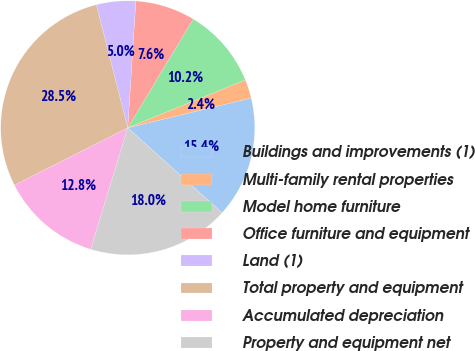Convert chart. <chart><loc_0><loc_0><loc_500><loc_500><pie_chart><fcel>Buildings and improvements (1)<fcel>Multi-family rental properties<fcel>Model home furniture<fcel>Office furniture and equipment<fcel>Land (1)<fcel>Total property and equipment<fcel>Accumulated depreciation<fcel>Property and equipment net<nl><fcel>15.44%<fcel>2.39%<fcel>10.22%<fcel>7.61%<fcel>5.0%<fcel>28.49%<fcel>12.83%<fcel>18.05%<nl></chart> 